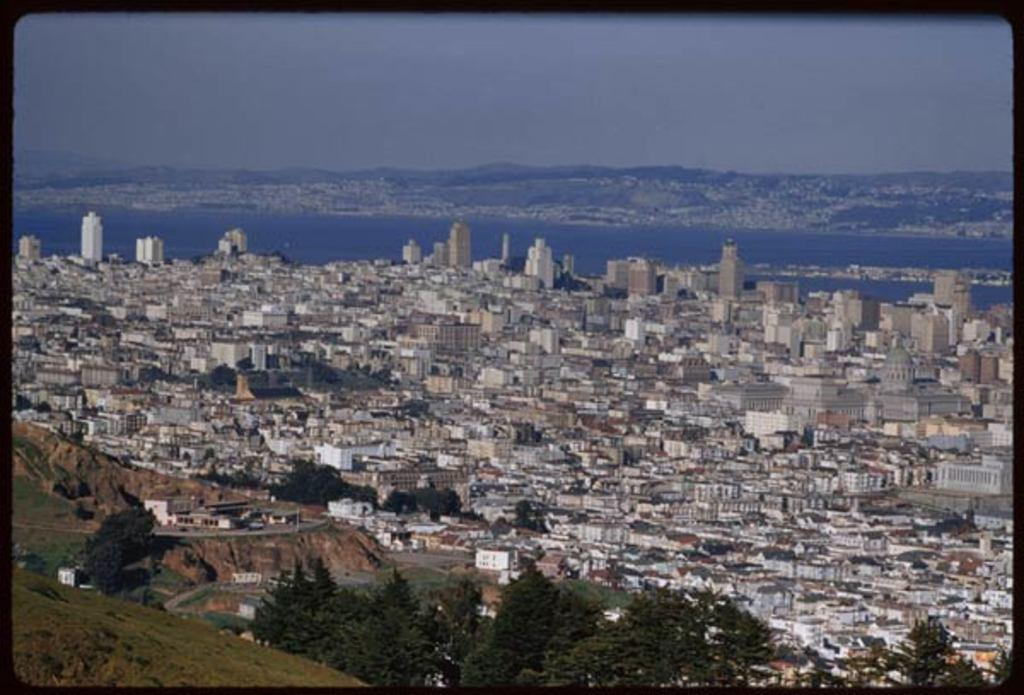What types of structures can be seen in the image? There are multiple buildings and houses in the image. What natural element is present in the image? There is a tree in the image. What geographical feature can be seen in the image? There is a hill in the image. What type of horn can be seen on the tree in the image? There is no horn present on the tree in the image. What material is the steel used for in the image? There is no steel present in the image. 